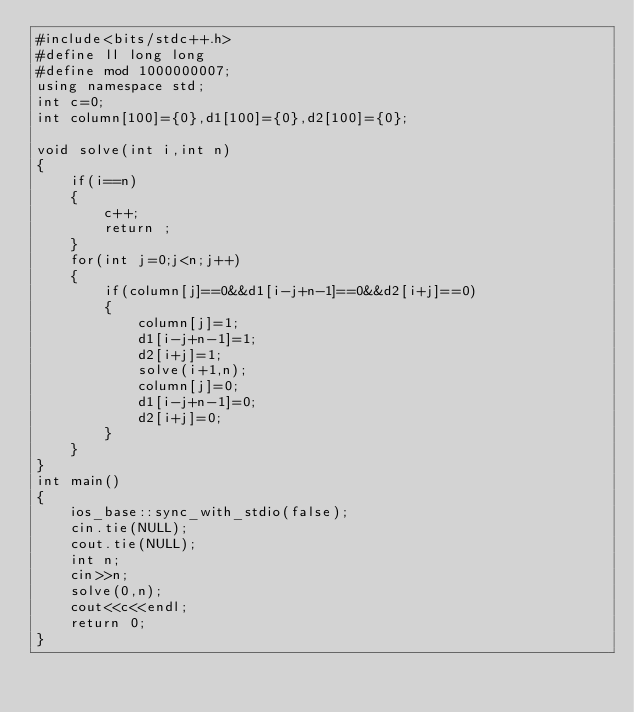Convert code to text. <code><loc_0><loc_0><loc_500><loc_500><_C++_>#include<bits/stdc++.h>
#define ll long long
#define mod 1000000007;
using namespace std;
int c=0;
int column[100]={0},d1[100]={0},d2[100]={0};

void solve(int i,int n)
{
    if(i==n)
    {
        c++;
        return ;
    }
    for(int j=0;j<n;j++)
    {
        if(column[j]==0&&d1[i-j+n-1]==0&&d2[i+j]==0)
        {
            column[j]=1;
            d1[i-j+n-1]=1;
            d2[i+j]=1;
            solve(i+1,n);
            column[j]=0;
            d1[i-j+n-1]=0;
            d2[i+j]=0;
        }
    }
}
int main()
{
    ios_base::sync_with_stdio(false);
    cin.tie(NULL);
    cout.tie(NULL);
    int n;
    cin>>n;
    solve(0,n);
    cout<<c<<endl;
    return 0;
}
</code> 